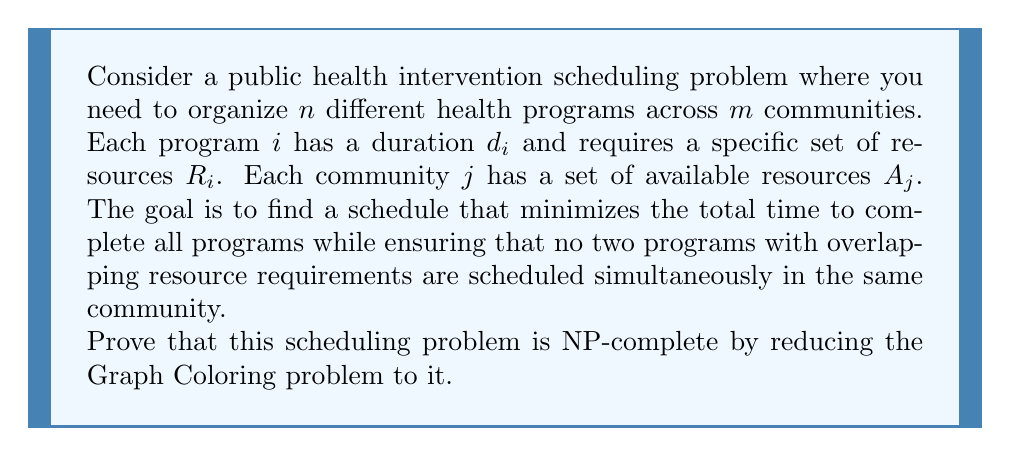Could you help me with this problem? To prove that the public health intervention scheduling problem is NP-complete, we need to show that it is both in NP and NP-hard. We'll focus on proving it's NP-hard by reducing the Graph Coloring problem to our scheduling problem.

1. First, let's establish that the problem is in NP:
   - A solution can be verified in polynomial time by checking if all programs are scheduled, resource constraints are met, and the total time is minimized.

2. Now, we'll reduce the Graph Coloring problem to our scheduling problem:

   a) Given an instance of the Graph Coloring problem with a graph $G=(V,E)$ and $k$ colors:
      - Let $V = \{v_1, v_2, ..., v_n\}$ be the set of vertices
      - Let $E$ be the set of edges

   b) Construct an instance of our scheduling problem:
      - Create $n$ programs, one for each vertex: $P = \{p_1, p_2, ..., p_n\}$
      - Set all program durations $d_i = 1$
      - Create $k$ communities, one for each color: $C = \{c_1, c_2, ..., c_k\}$
      - For each program $p_i$, set its resource requirement $R_i = \{r_i\}$ (a unique resource)
      - For each community $c_j$, set its available resources $A_j = \{r_1, r_2, ..., r_n\}$

   c) Add constraints:
      - For each edge $(v_i, v_j)$ in $E$, add a constraint that programs $p_i$ and $p_j$ cannot be scheduled simultaneously in the same community

   d) Set the goal to minimize the total time to complete all programs

3. This reduction is polynomial-time computable.

4. Now, we need to show that a solution to the Graph Coloring problem exists if and only if there exists a solution to our scheduling problem with a total time of 1:

   - If the Graph Coloring problem has a solution with $k$ colors, we can schedule all programs in our problem in one time slot across $k$ communities, satisfying all constraints.
   - Conversely, if our scheduling problem has a solution with total time 1, it means all programs are scheduled in one time slot across $k$ communities without violating any constraints. This directly corresponds to a valid $k$-coloring of the original graph.

5. Since the Graph Coloring problem is known to be NP-complete, and we've reduced it to our scheduling problem, our problem is also NP-hard.

Therefore, as the public health intervention scheduling problem is both in NP and NP-hard, it is NP-complete.
Answer: The public health intervention scheduling problem, as described, is NP-complete. This is proven by showing that the problem is in NP and reducing the known NP-complete Graph Coloring problem to it in polynomial time. 